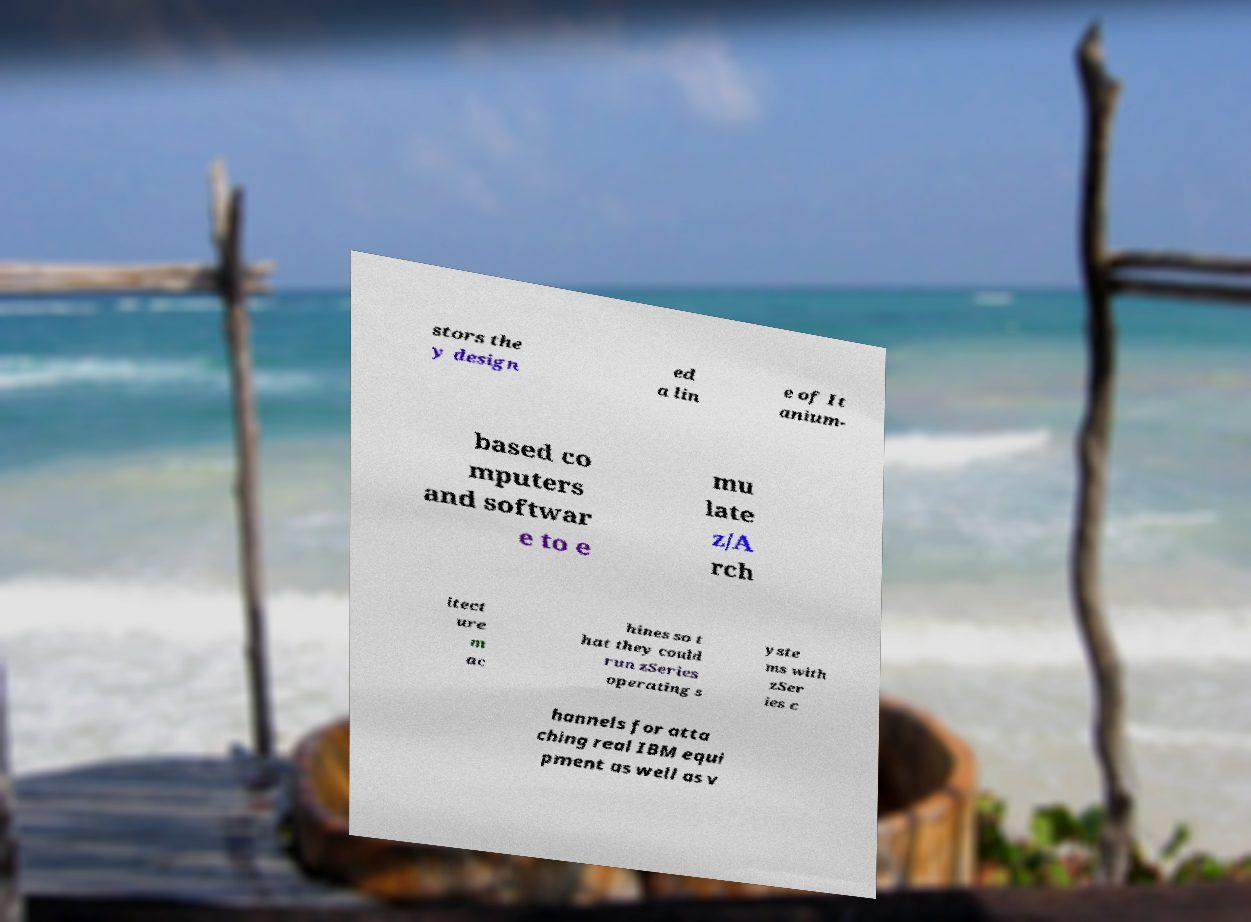Could you assist in decoding the text presented in this image and type it out clearly? stors the y design ed a lin e of It anium- based co mputers and softwar e to e mu late z/A rch itect ure m ac hines so t hat they could run zSeries operating s yste ms with zSer ies c hannels for atta ching real IBM equi pment as well as v 